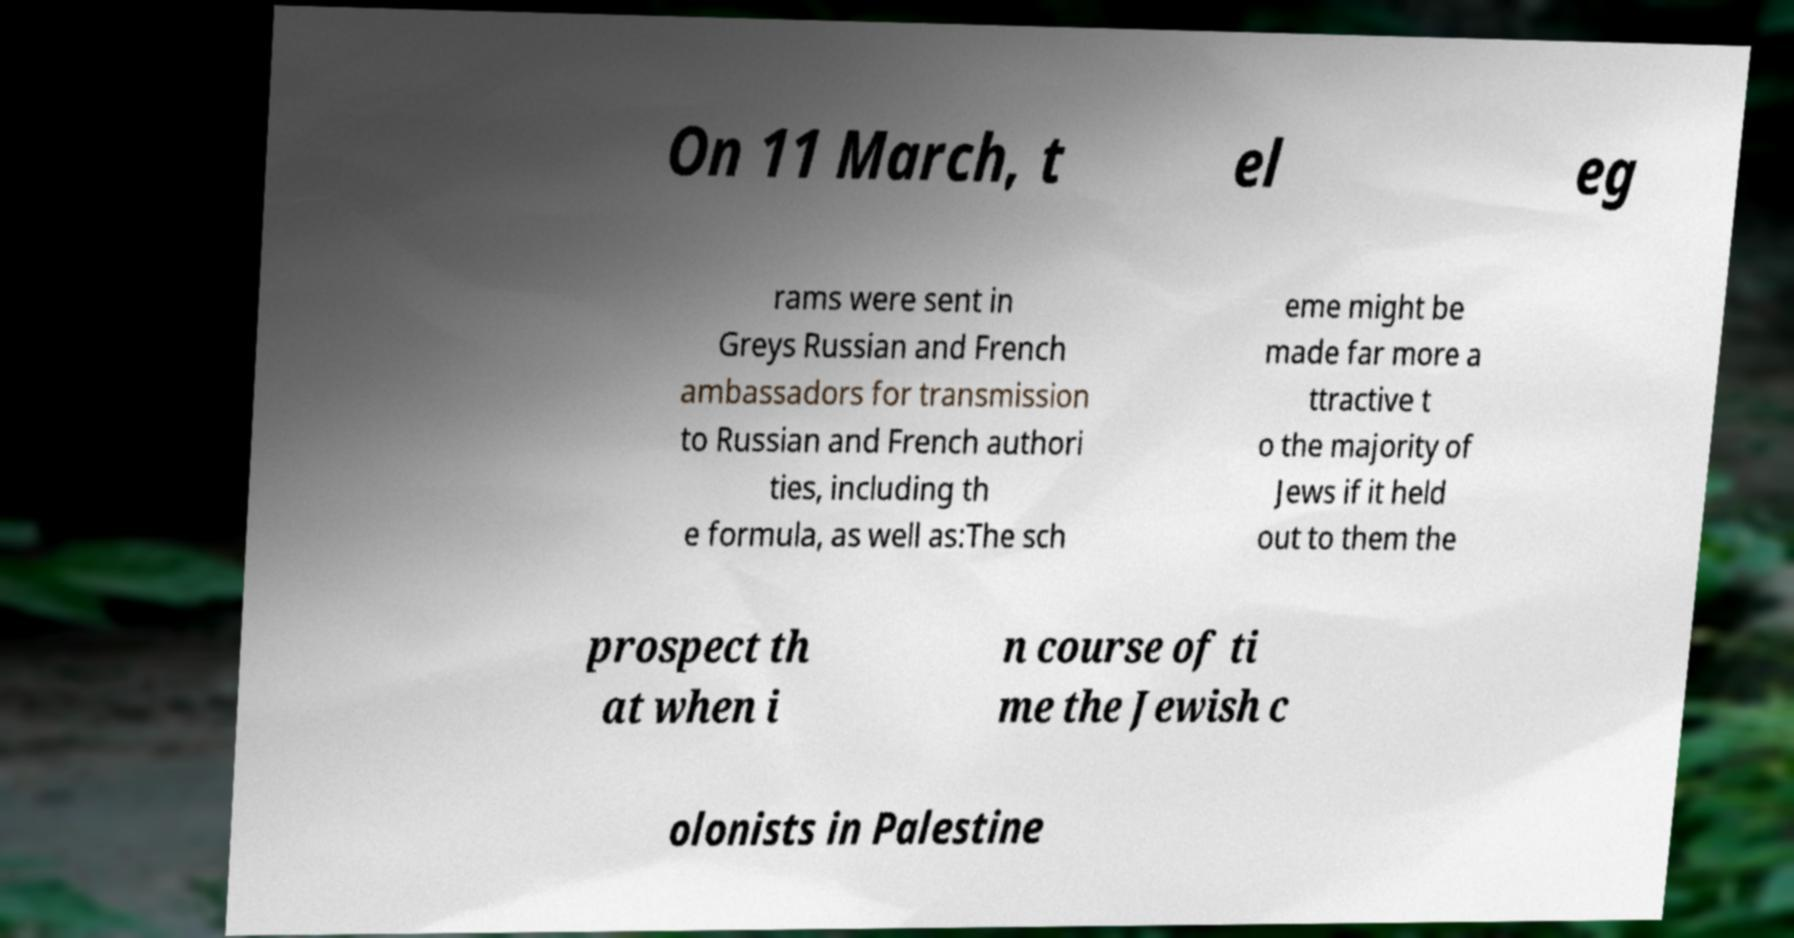Can you accurately transcribe the text from the provided image for me? On 11 March, t el eg rams were sent in Greys Russian and French ambassadors for transmission to Russian and French authori ties, including th e formula, as well as:The sch eme might be made far more a ttractive t o the majority of Jews if it held out to them the prospect th at when i n course of ti me the Jewish c olonists in Palestine 